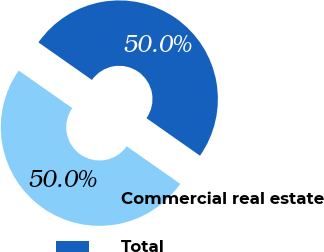Convert chart to OTSL. <chart><loc_0><loc_0><loc_500><loc_500><pie_chart><fcel>Commercial real estate<fcel>Total<nl><fcel>50.0%<fcel>50.0%<nl></chart> 